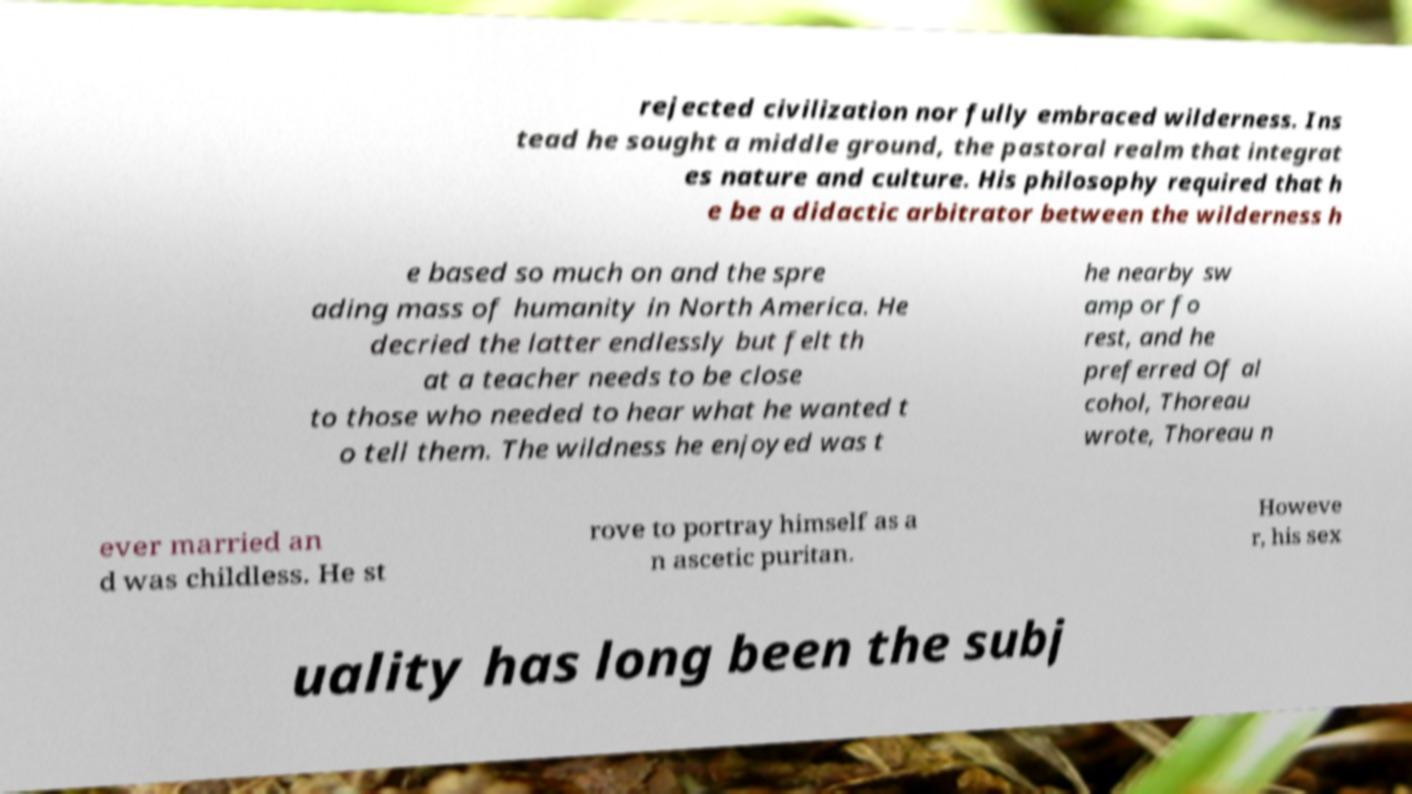Can you accurately transcribe the text from the provided image for me? rejected civilization nor fully embraced wilderness. Ins tead he sought a middle ground, the pastoral realm that integrat es nature and culture. His philosophy required that h e be a didactic arbitrator between the wilderness h e based so much on and the spre ading mass of humanity in North America. He decried the latter endlessly but felt th at a teacher needs to be close to those who needed to hear what he wanted t o tell them. The wildness he enjoyed was t he nearby sw amp or fo rest, and he preferred Of al cohol, Thoreau wrote, Thoreau n ever married an d was childless. He st rove to portray himself as a n ascetic puritan. Howeve r, his sex uality has long been the subj 